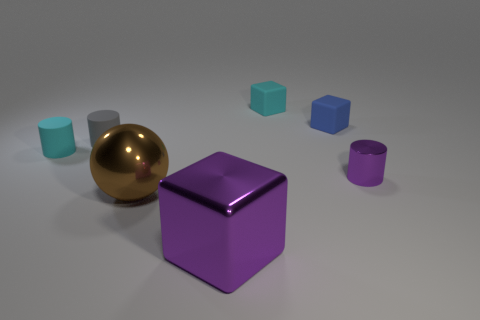Subtract 1 cubes. How many cubes are left? 2 Subtract all matte cylinders. How many cylinders are left? 1 Add 2 purple rubber spheres. How many objects exist? 9 Subtract all spheres. How many objects are left? 6 Add 1 tiny metal things. How many tiny metal things are left? 2 Add 3 gray cylinders. How many gray cylinders exist? 4 Subtract 0 gray blocks. How many objects are left? 7 Subtract all cyan blocks. Subtract all large metallic objects. How many objects are left? 4 